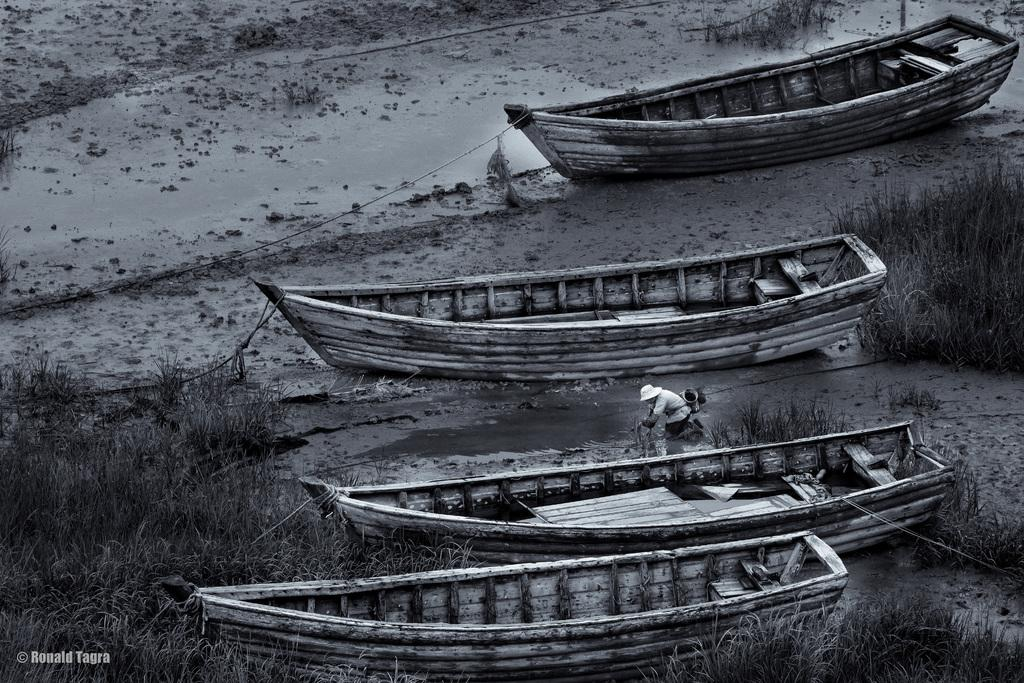What type of vehicles can be seen in the image? There are boats in the image. What type of vegetation is visible in the image? There is grass visible in the image. Can you describe the person's location in the image? There is a person standing on mud in the image. What type of wool can be seen on the floor in the image? There is no wool or floor present in the image; it features boats, grass, and a person standing on mud. 